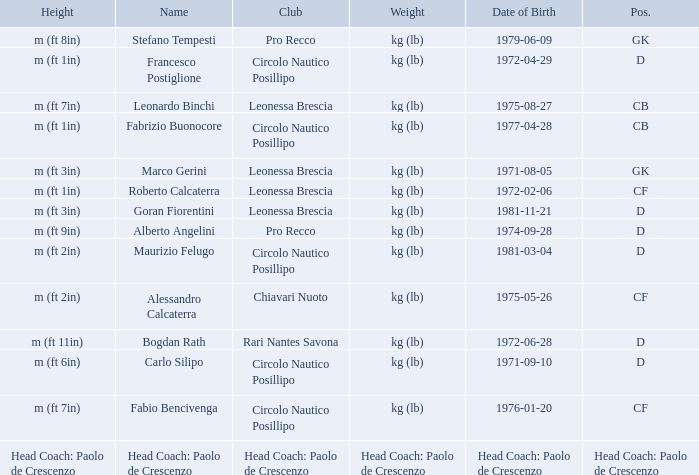What is the weight of the entry that has a date of birth of 1981-11-21? Kg (lb). Would you be able to parse every entry in this table? {'header': ['Height', 'Name', 'Club', 'Weight', 'Date of Birth', 'Pos.'], 'rows': [['m (ft 8in)', 'Stefano Tempesti', 'Pro Recco', 'kg (lb)', '1979-06-09', 'GK'], ['m (ft 1in)', 'Francesco Postiglione', 'Circolo Nautico Posillipo', 'kg (lb)', '1972-04-29', 'D'], ['m (ft 7in)', 'Leonardo Binchi', 'Leonessa Brescia', 'kg (lb)', '1975-08-27', 'CB'], ['m (ft 1in)', 'Fabrizio Buonocore', 'Circolo Nautico Posillipo', 'kg (lb)', '1977-04-28', 'CB'], ['m (ft 3in)', 'Marco Gerini', 'Leonessa Brescia', 'kg (lb)', '1971-08-05', 'GK'], ['m (ft 1in)', 'Roberto Calcaterra', 'Leonessa Brescia', 'kg (lb)', '1972-02-06', 'CF'], ['m (ft 3in)', 'Goran Fiorentini', 'Leonessa Brescia', 'kg (lb)', '1981-11-21', 'D'], ['m (ft 9in)', 'Alberto Angelini', 'Pro Recco', 'kg (lb)', '1974-09-28', 'D'], ['m (ft 2in)', 'Maurizio Felugo', 'Circolo Nautico Posillipo', 'kg (lb)', '1981-03-04', 'D'], ['m (ft 2in)', 'Alessandro Calcaterra', 'Chiavari Nuoto', 'kg (lb)', '1975-05-26', 'CF'], ['m (ft 11in)', 'Bogdan Rath', 'Rari Nantes Savona', 'kg (lb)', '1972-06-28', 'D'], ['m (ft 6in)', 'Carlo Silipo', 'Circolo Nautico Posillipo', 'kg (lb)', '1971-09-10', 'D'], ['m (ft 7in)', 'Fabio Bencivenga', 'Circolo Nautico Posillipo', 'kg (lb)', '1976-01-20', 'CF'], ['Head Coach: Paolo de Crescenzo', 'Head Coach: Paolo de Crescenzo', 'Head Coach: Paolo de Crescenzo', 'Head Coach: Paolo de Crescenzo', 'Head Coach: Paolo de Crescenzo', 'Head Coach: Paolo de Crescenzo']]} 